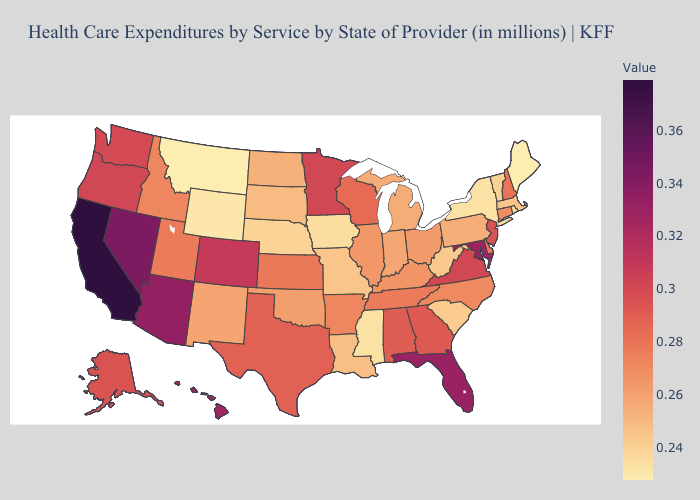Does Hawaii have the highest value in the USA?
Concise answer only. No. Does California have the highest value in the USA?
Short answer required. Yes. Does Utah have the highest value in the West?
Answer briefly. No. Among the states that border Virginia , which have the highest value?
Short answer required. Maryland. Which states have the highest value in the USA?
Answer briefly. California. 